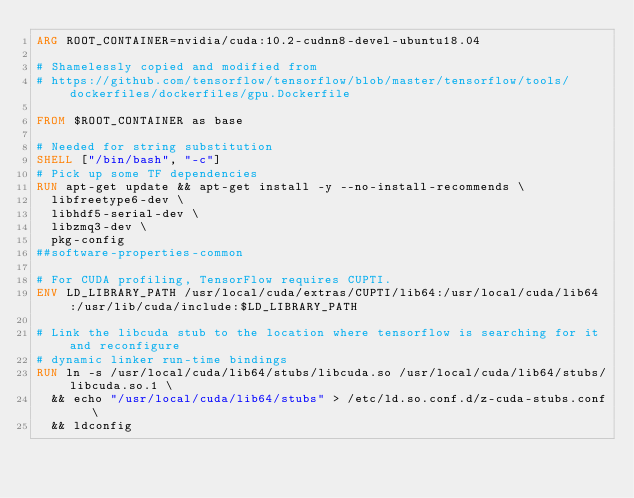<code> <loc_0><loc_0><loc_500><loc_500><_Dockerfile_>ARG ROOT_CONTAINER=nvidia/cuda:10.2-cudnn8-devel-ubuntu18.04

# Shamelessly copied and modified from
# https://github.com/tensorflow/tensorflow/blob/master/tensorflow/tools/dockerfiles/dockerfiles/gpu.Dockerfile

FROM $ROOT_CONTAINER as base

# Needed for string substitution
SHELL ["/bin/bash", "-c"]
# Pick up some TF dependencies
RUN apt-get update && apt-get install -y --no-install-recommends \
  libfreetype6-dev \
  libhdf5-serial-dev \
  libzmq3-dev \
  pkg-config
##software-properties-common

# For CUDA profiling, TensorFlow requires CUPTI.
ENV LD_LIBRARY_PATH /usr/local/cuda/extras/CUPTI/lib64:/usr/local/cuda/lib64:/usr/lib/cuda/include:$LD_LIBRARY_PATH

# Link the libcuda stub to the location where tensorflow is searching for it and reconfigure
# dynamic linker run-time bindings
RUN ln -s /usr/local/cuda/lib64/stubs/libcuda.so /usr/local/cuda/lib64/stubs/libcuda.so.1 \
  && echo "/usr/local/cuda/lib64/stubs" > /etc/ld.so.conf.d/z-cuda-stubs.conf \
  && ldconfig
</code> 